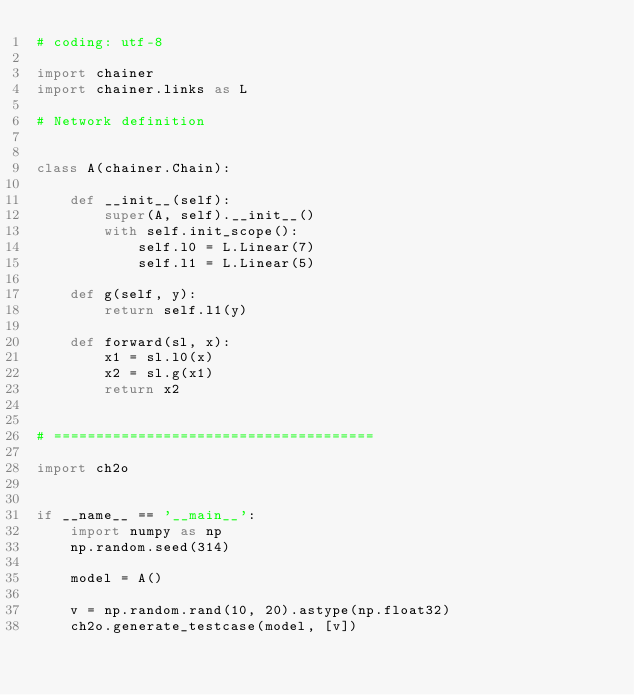<code> <loc_0><loc_0><loc_500><loc_500><_Python_># coding: utf-8

import chainer
import chainer.links as L

# Network definition


class A(chainer.Chain):

    def __init__(self):
        super(A, self).__init__()
        with self.init_scope():
            self.l0 = L.Linear(7)
            self.l1 = L.Linear(5)

    def g(self, y):
        return self.l1(y)

    def forward(sl, x):
        x1 = sl.l0(x)
        x2 = sl.g(x1)
        return x2


# ======================================

import ch2o


if __name__ == '__main__':
    import numpy as np
    np.random.seed(314)

    model = A()

    v = np.random.rand(10, 20).astype(np.float32)
    ch2o.generate_testcase(model, [v])
</code> 